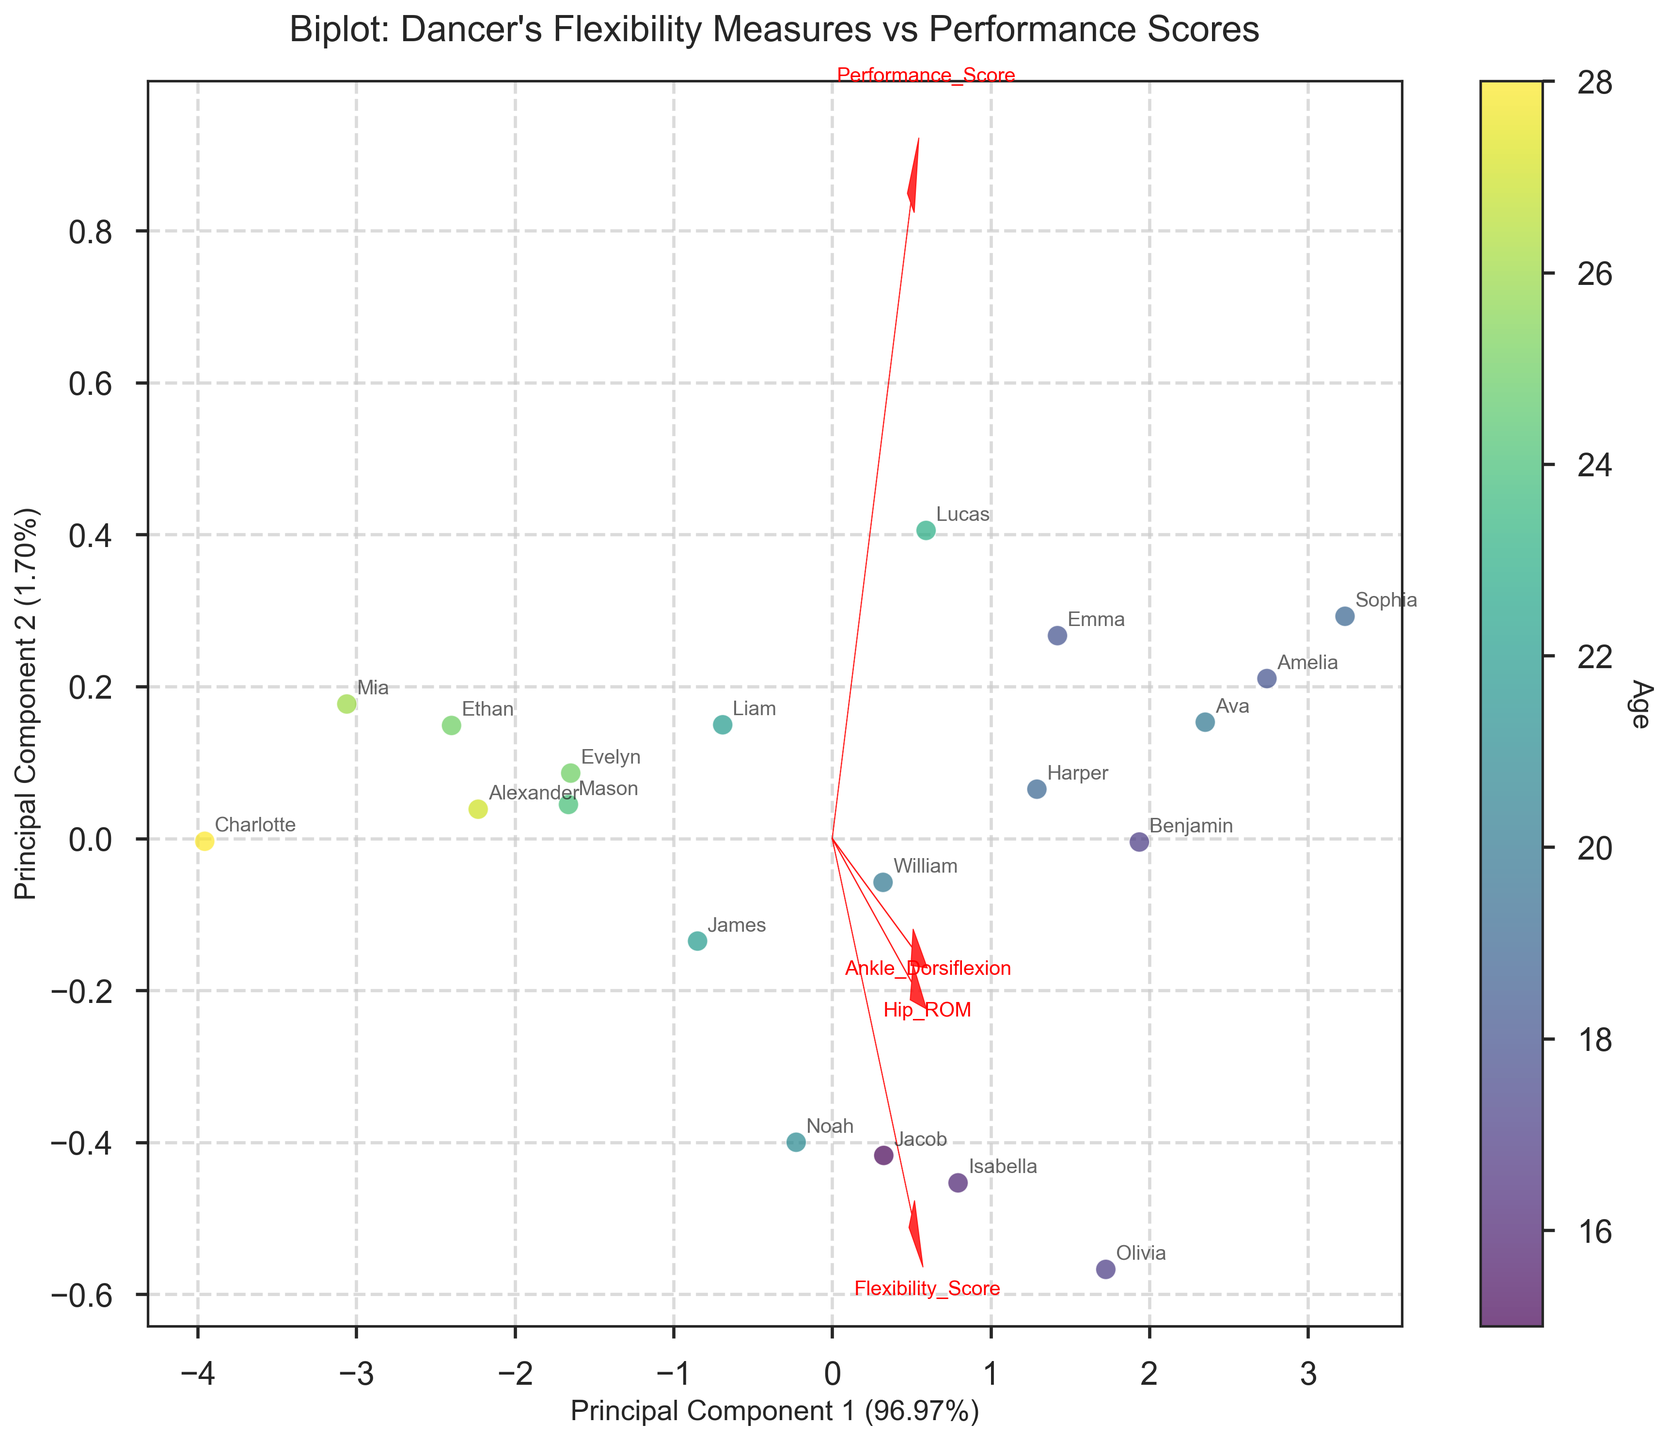What's the title of the figure? The title of the figure is usually located at the top and indicates the main focus or subject of the plot.
Answer: "Biplot: Dancer's Flexibility Measures vs Performance Scores" What are the labels for the x-axis and y-axis? The labels for the axes usually describe the principal components represented. Look at the text near the x and y axes.
Answer: x-axis: "Principal Component 1", y-axis: "Principal Component 2" What do the colors of the data points represent? The colors of the data points visually encode the age of the dancers, facilitated by a color gradient from younger to older ages.
Answer: Age Which flexibility measure appears to have the strongest relationship with Principal Component 1? Observe the arrow directions and their lengths in relation to Principal Component 1 to determine which feature vector has the strongest loading.
Answer: "Hip_ROM" Which dancer appears to have the highest combined score for flexibility and performance? Look for the data point that is farthest in the direction of flexibility and performance score arrows. Then, check the annotation near the point.
Answer: Sophia Between Flexibility Score and Ankle Dorsiflexion, which measure contributes more to Principal Component 2? Compare the projection lengths of the two vectors (Flexibility Score and Ankle Dorsiflexion) on Principal Component 2. Longer vectors indicate a stronger influence.
Answer: Flexibility Score How does the performance score change with age? Observe the gradient in color as it relates to the spread of performance scores in the plot.
Answer: Generally decreases Which age group (15-18, 19-22, 23-28) clusters more prominently in the top left quadrant of the plot? Identify data points within the top left quadrant and compile the corresponding ages, then categorize them based on the given age groups.
Answer: 19-22 What is the approximate percentage of variation explained by Principal Component 1? This information is found in the x-axis label indicating the principal component and its percentage of variance explained.
Answer: About 50% Which two flexibility measures appear to be the least correlated based on their vectors? Vectors that are closer to orthogonal (90 degrees apart) indicate features that are not highly correlated. Compare the angle between different pairs of vectors.
Answer: Performance Score and Ankle Dorsiflexion 